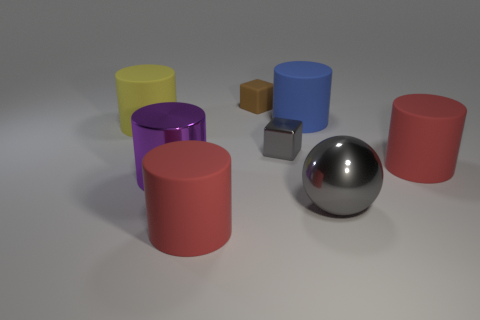Add 1 small cyan matte cylinders. How many objects exist? 9 Subtract all balls. How many objects are left? 7 Subtract 0 brown spheres. How many objects are left? 8 Subtract all red rubber things. Subtract all small brown rubber objects. How many objects are left? 5 Add 4 large blue rubber cylinders. How many large blue rubber cylinders are left? 5 Add 3 matte cylinders. How many matte cylinders exist? 7 